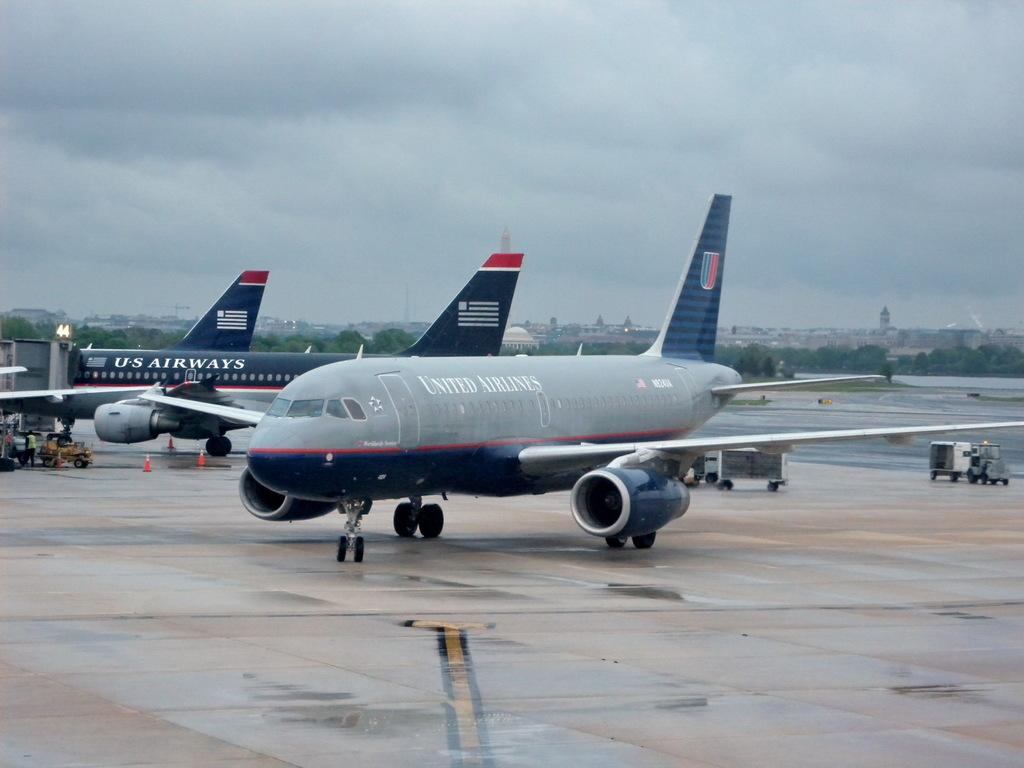<image>
Give a short and clear explanation of the subsequent image. A number of United Airlines planes on the tarmac on an overcast day. 